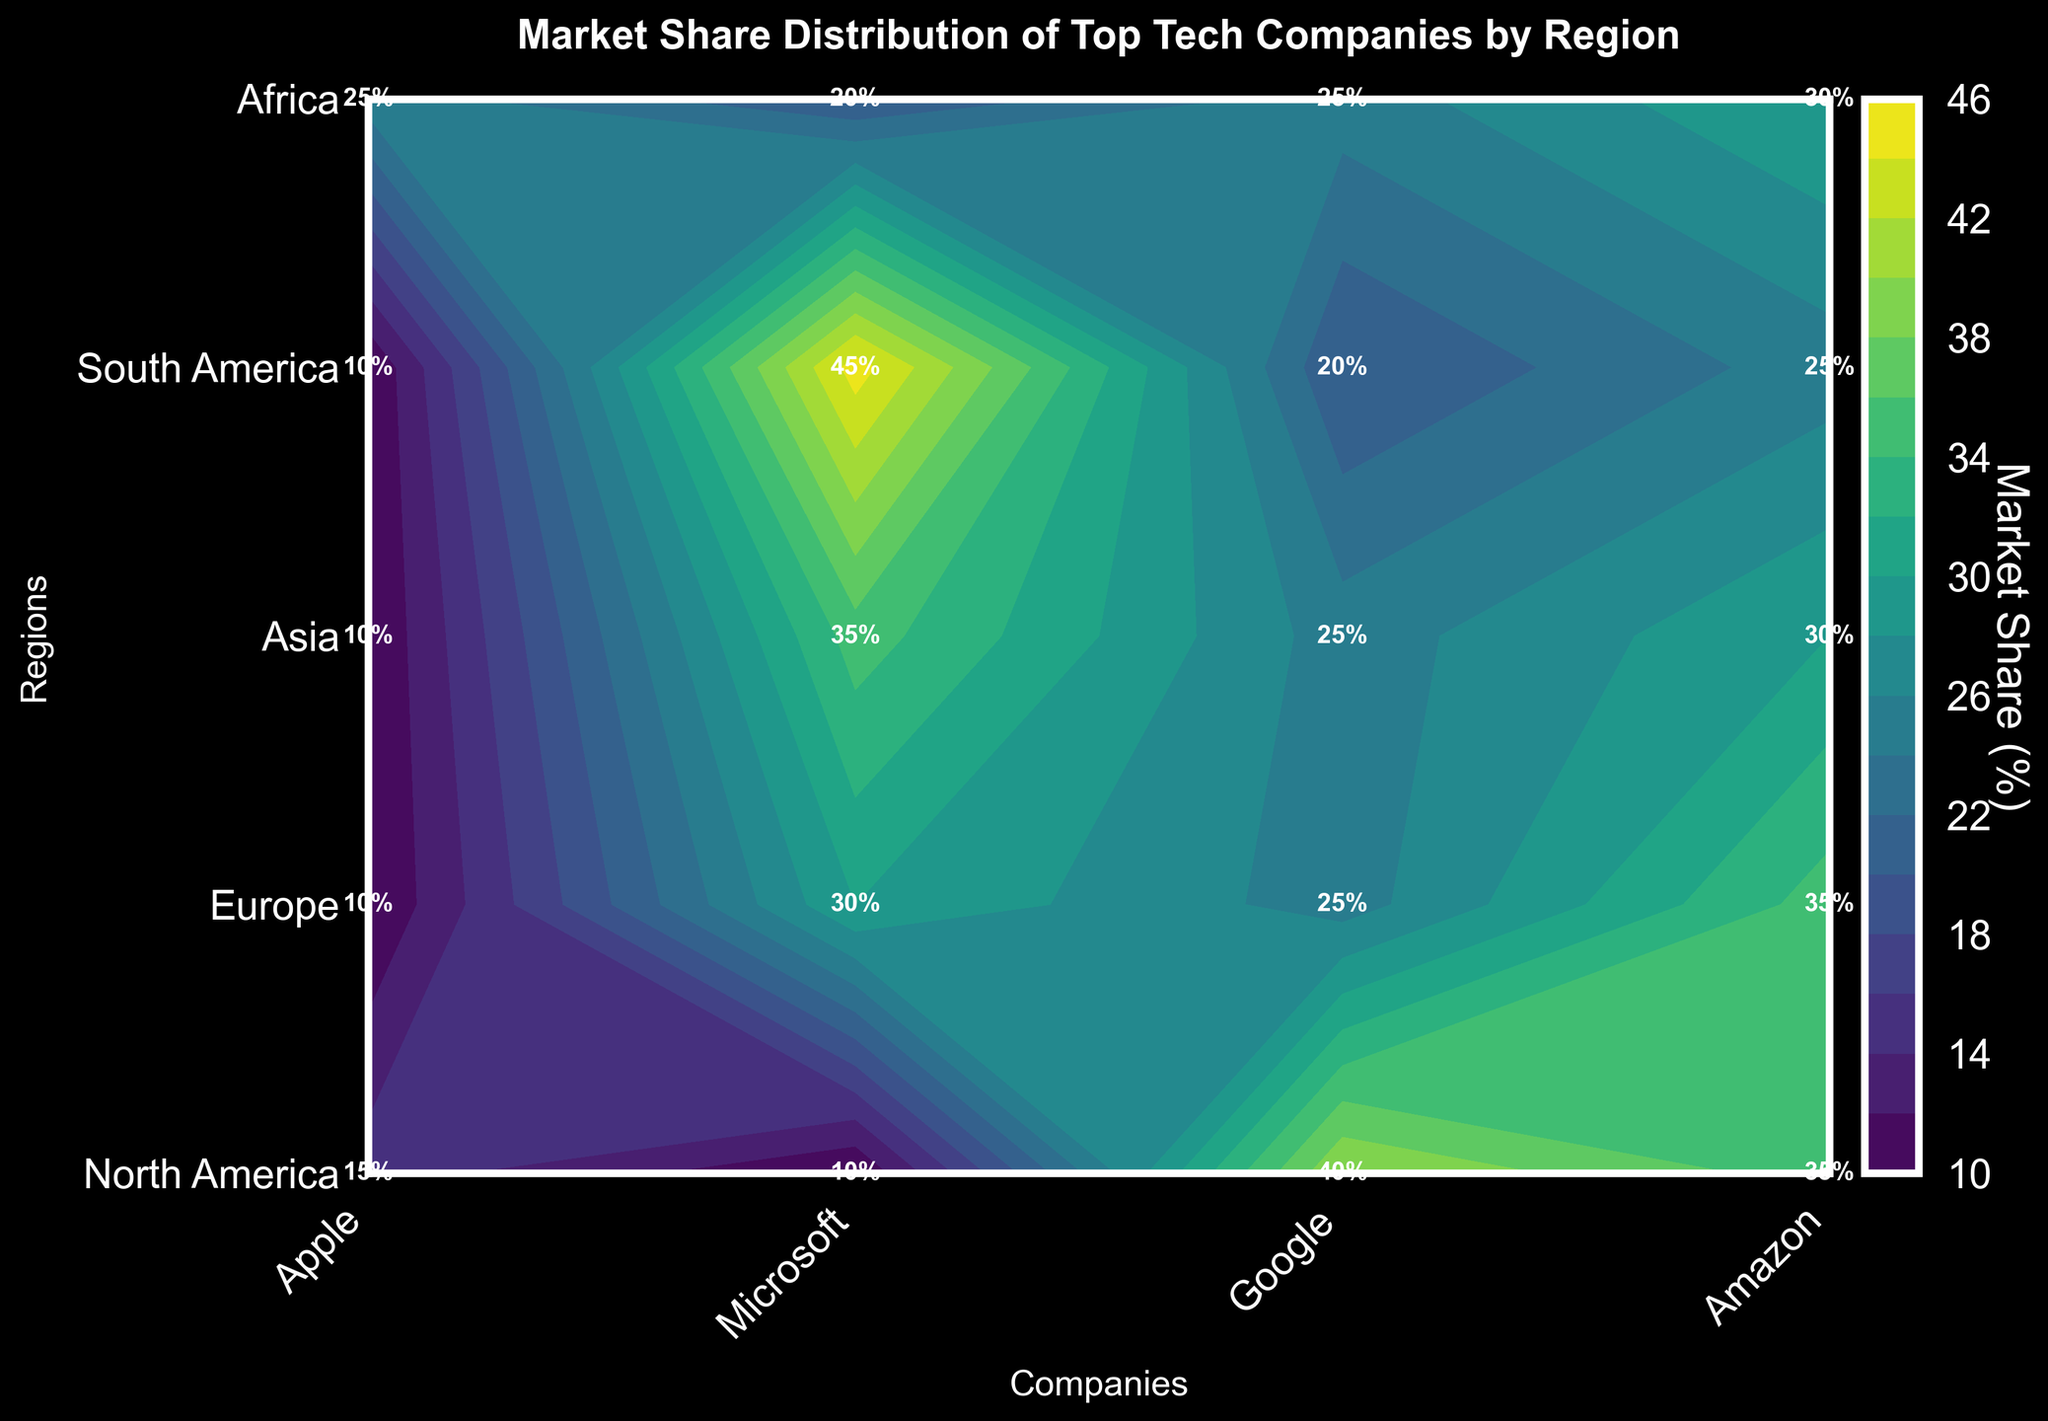What is the title of the plot? The title of the plot is typically located at the top center of the graphic. This one reads "Market Share Distribution of Top Tech Companies by Region."
Answer: Market Share Distribution of Top Tech Companies by Region Which region has the highest market share for Google? To find this, look at the y-axis labels for regions, then trace the columns labeled Google. The label with the highest percentage is the answer.
Answer: Africa What is the average market share of Microsoft across all regions? Sum the market shares of Microsoft for all listed regions (25 + 30 + 35 + 30 + 35 = 155), then divide by the number of regions (5). So, 155 / 5 = 31%.
Answer: 31% Between Apple and Amazon, which company has the smallest market share in Europe? Look at the cell intersection for Europe and Apple, and Europe and Amazon. Compare the percentages.
Answer: Amazon What is the difference in market share between Apple in North America and Apple in Africa? Subtract the market share of Apple in Africa (10) from the market share in North America (45) which is 45 - 10 = 35.
Answer: 35 Which company has the most even distribution of market share across different regions? Look for the company whose market share values vary the least across all regions. Compare the market share of each company for all regions. Apple has the widest range, followed by Microsoft, and so forth.
Answer: Amazon What is the combined market share for all companies in Asia? Add the market shares for Asia across all companies: 30 (Apple) + 35 (Microsoft) + 25 (Google) + 10 (Amazon) equals 100%.
Answer: 100% Is there any region where Amazon has a market share equal to or greater than Apple? Check each region where Amazon's market share is compared with Apple's. North America, Europe, Asia, and Africa do not meet this condition, but in South America, both companies have equal market shares of 25%.
Answer: South America In which region is Microsoft's market share more than double that of Amazon's? Check each region if Microsoft's market share > 2 * Amazon's market share. In North America (25 > 20), Europe (30 > 20), Asia (35 > 20), South America (30 > 50), and Africa (35 > 30).
Answer: Africa 